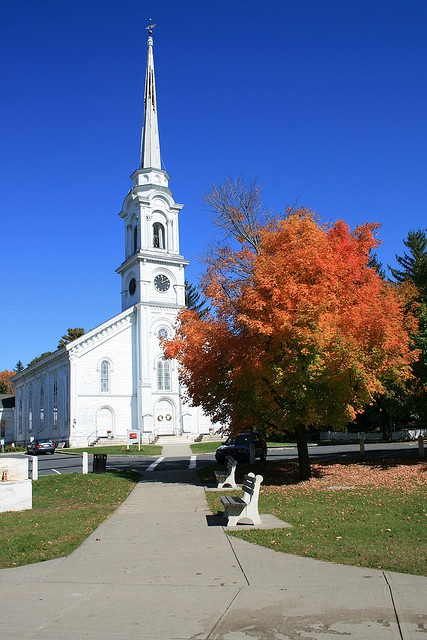Describe the objects in this image and their specific colors. I can see bench in darkblue, lightgray, black, gray, and darkgray tones, car in darkblue, black, navy, gray, and darkgreen tones, bench in darkblue, black, lightgray, gray, and darkgray tones, car in darkblue, black, navy, gray, and blue tones, and clock in darkblue, gray, darkgray, and ivory tones in this image. 